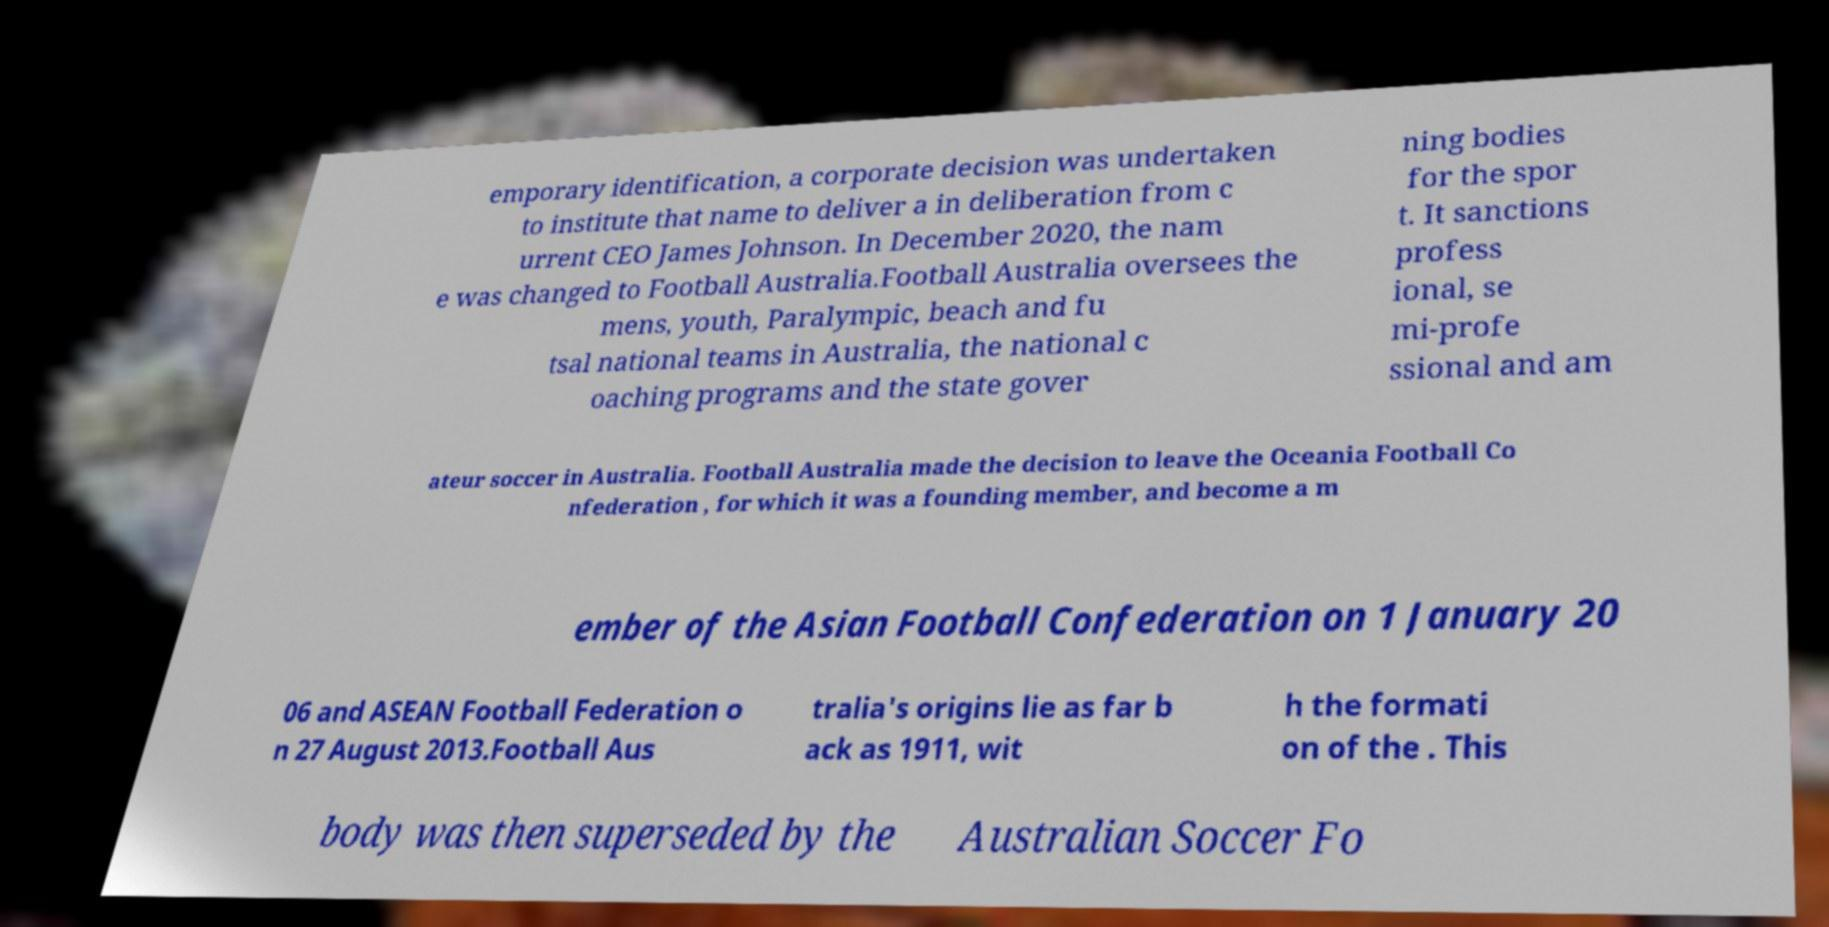Can you read and provide the text displayed in the image?This photo seems to have some interesting text. Can you extract and type it out for me? emporary identification, a corporate decision was undertaken to institute that name to deliver a in deliberation from c urrent CEO James Johnson. In December 2020, the nam e was changed to Football Australia.Football Australia oversees the mens, youth, Paralympic, beach and fu tsal national teams in Australia, the national c oaching programs and the state gover ning bodies for the spor t. It sanctions profess ional, se mi-profe ssional and am ateur soccer in Australia. Football Australia made the decision to leave the Oceania Football Co nfederation , for which it was a founding member, and become a m ember of the Asian Football Confederation on 1 January 20 06 and ASEAN Football Federation o n 27 August 2013.Football Aus tralia's origins lie as far b ack as 1911, wit h the formati on of the . This body was then superseded by the Australian Soccer Fo 